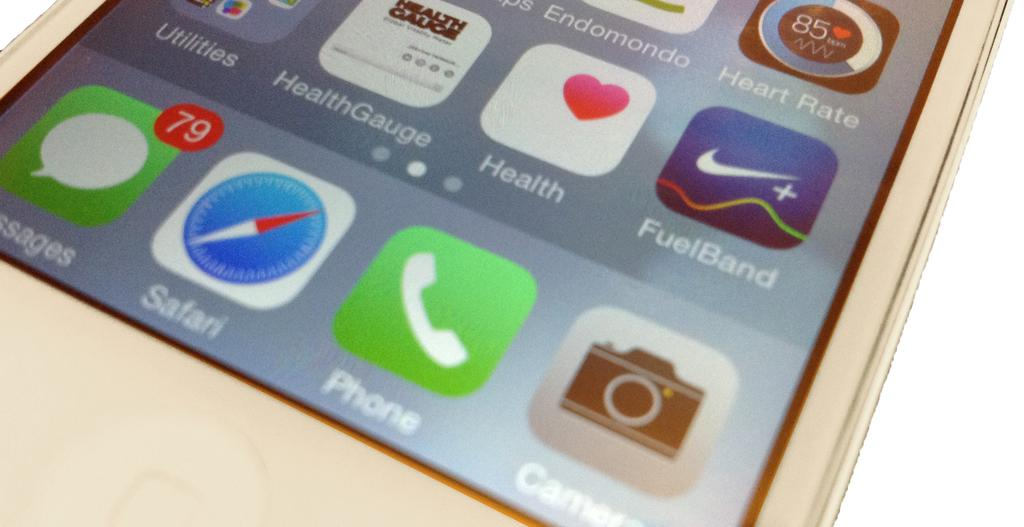Provide a one-sentence caption for the provided image. An iphone that has apps like FuelBand, Health Gauge, and Heart Rate on it. 